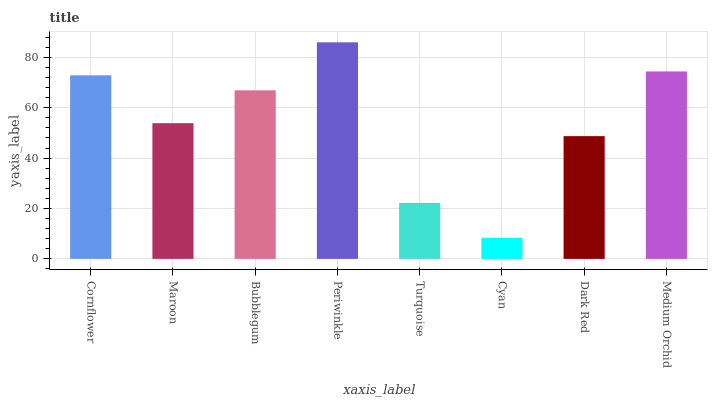Is Cyan the minimum?
Answer yes or no. Yes. Is Periwinkle the maximum?
Answer yes or no. Yes. Is Maroon the minimum?
Answer yes or no. No. Is Maroon the maximum?
Answer yes or no. No. Is Cornflower greater than Maroon?
Answer yes or no. Yes. Is Maroon less than Cornflower?
Answer yes or no. Yes. Is Maroon greater than Cornflower?
Answer yes or no. No. Is Cornflower less than Maroon?
Answer yes or no. No. Is Bubblegum the high median?
Answer yes or no. Yes. Is Maroon the low median?
Answer yes or no. Yes. Is Maroon the high median?
Answer yes or no. No. Is Cyan the low median?
Answer yes or no. No. 